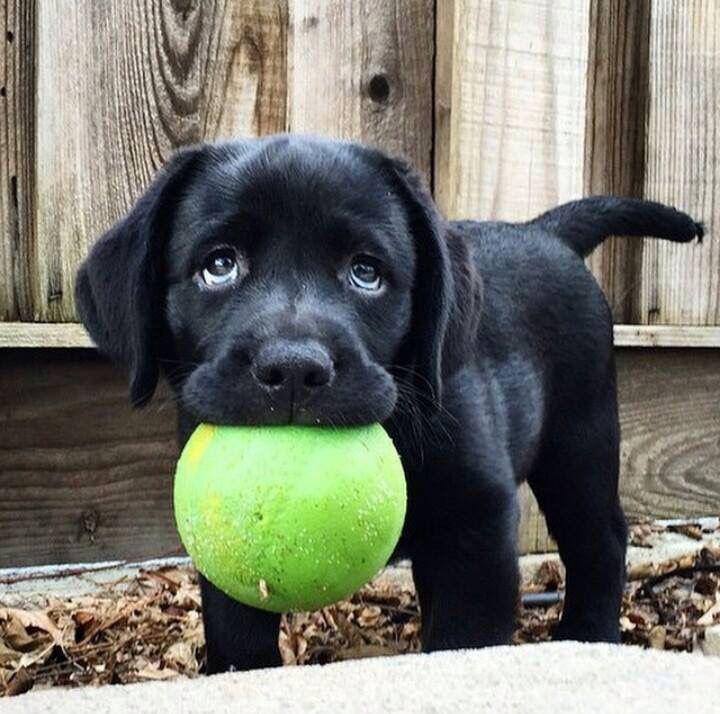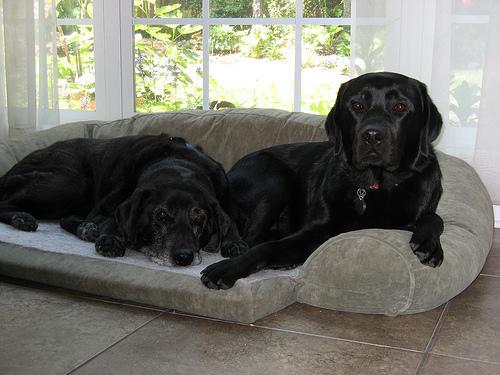The first image is the image on the left, the second image is the image on the right. Analyze the images presented: Is the assertion "A dog is lying on a couch with its head down." valid? Answer yes or no. Yes. The first image is the image on the left, the second image is the image on the right. For the images displayed, is the sentence "An image shows two dogs reclining together on something indoors, with a white fabric under them." factually correct? Answer yes or no. Yes. 